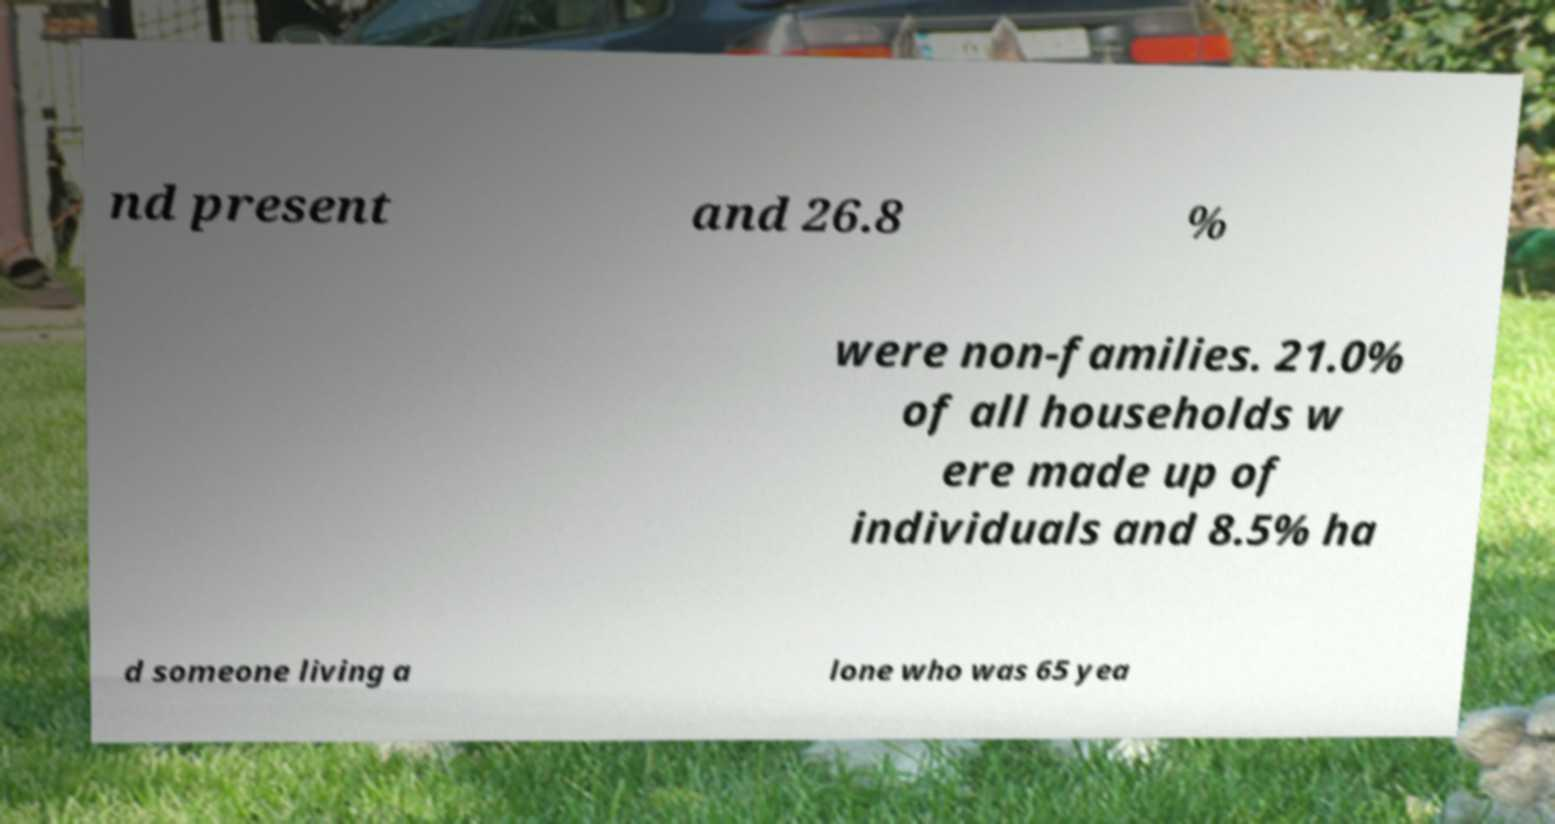Can you read and provide the text displayed in the image?This photo seems to have some interesting text. Can you extract and type it out for me? nd present and 26.8 % were non-families. 21.0% of all households w ere made up of individuals and 8.5% ha d someone living a lone who was 65 yea 